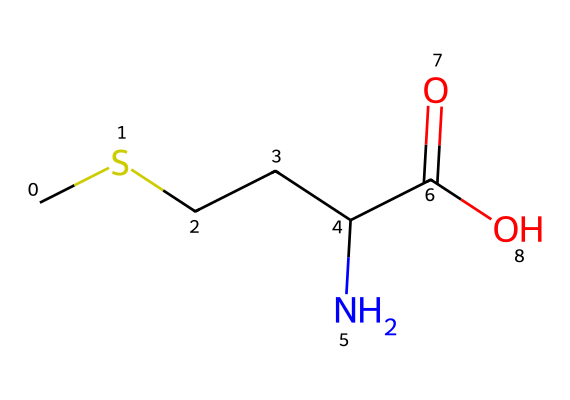How many carbon atoms are present in methionine? By analyzing the SMILES representation, we see "C" appears five times, indicating there are five carbon atoms in the structure.
Answer: five What functional group is present in methionine? The "C(=O)O" portion of the SMILES represents a carboxylic acid functional group, characterized by its carbonyl (C=O) and hydroxyl (O-H) components.
Answer: carboxylic acid How many nitrogen atoms does methionine contain? Observing the SMILES, there is a "N" present, suggesting there is one nitrogen atom in the chemical structure of methionine.
Answer: one Does methionine contain sulfur? The “S” is absent in the SMILES representation, meaning that there is no sulfur atom in the structure of methionine, despite it being an organosulfur amino acid.
Answer: no What type of compound is methionine classified as? Methionine is an amino acid, as indicated by the presence of both an amino group ("N") and a carboxylic acid group ("C(=O)O") in its structure.
Answer: amino acid What is the total number of oxygen atoms in methionine? In the SMILES representation, there are two "O" characters, indicating that there are two oxygen atoms in the molecular structure of methionine.
Answer: two What distinguishes methionine from other amino acids in terms of its structure? Methionine is unique among amino acids due to the presence of a thioether (sulfur) in its side chain, represented in the "CS" fragment of the SMILES.
Answer: thioether 